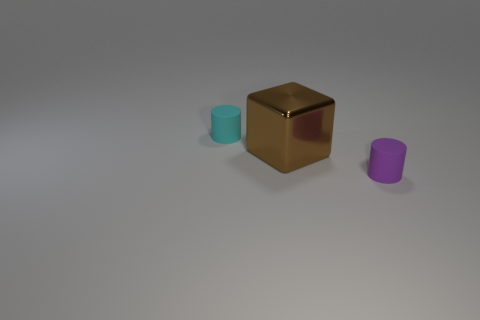What might be the purpose of these objects? The objects could serve a variety of purposes. The cube might be a decorative item, possibly a paperweight given its reflective and seemingly heavy appearance. The cylinders could be containers or parts of a larger mechanism. Without more context, it's hard to determine their exact function, but they seem to be simple geometric models perhaps used for display or educational purposes. 